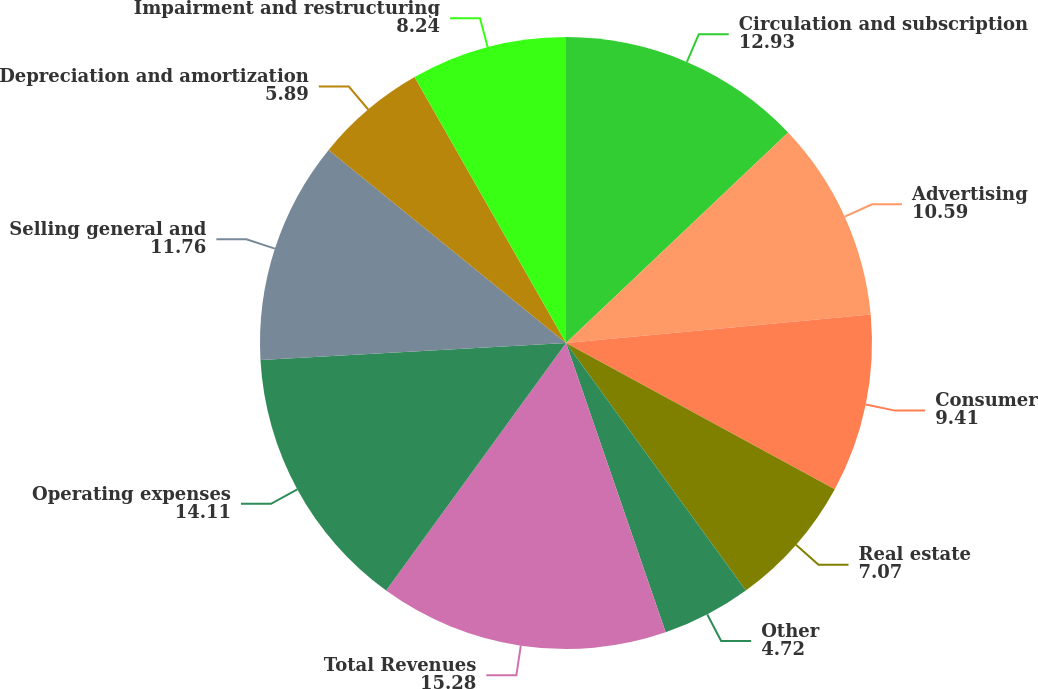<chart> <loc_0><loc_0><loc_500><loc_500><pie_chart><fcel>Circulation and subscription<fcel>Advertising<fcel>Consumer<fcel>Real estate<fcel>Other<fcel>Total Revenues<fcel>Operating expenses<fcel>Selling general and<fcel>Depreciation and amortization<fcel>Impairment and restructuring<nl><fcel>12.93%<fcel>10.59%<fcel>9.41%<fcel>7.07%<fcel>4.72%<fcel>15.28%<fcel>14.11%<fcel>11.76%<fcel>5.89%<fcel>8.24%<nl></chart> 